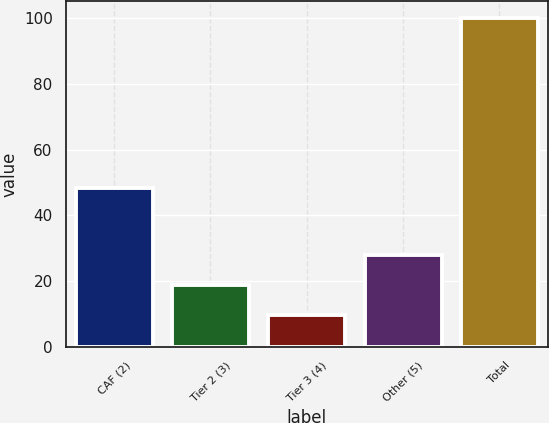<chart> <loc_0><loc_0><loc_500><loc_500><bar_chart><fcel>CAF (2)<fcel>Tier 2 (3)<fcel>Tier 3 (4)<fcel>Other (5)<fcel>Total<nl><fcel>48.4<fcel>18.91<fcel>9.9<fcel>27.92<fcel>100<nl></chart> 